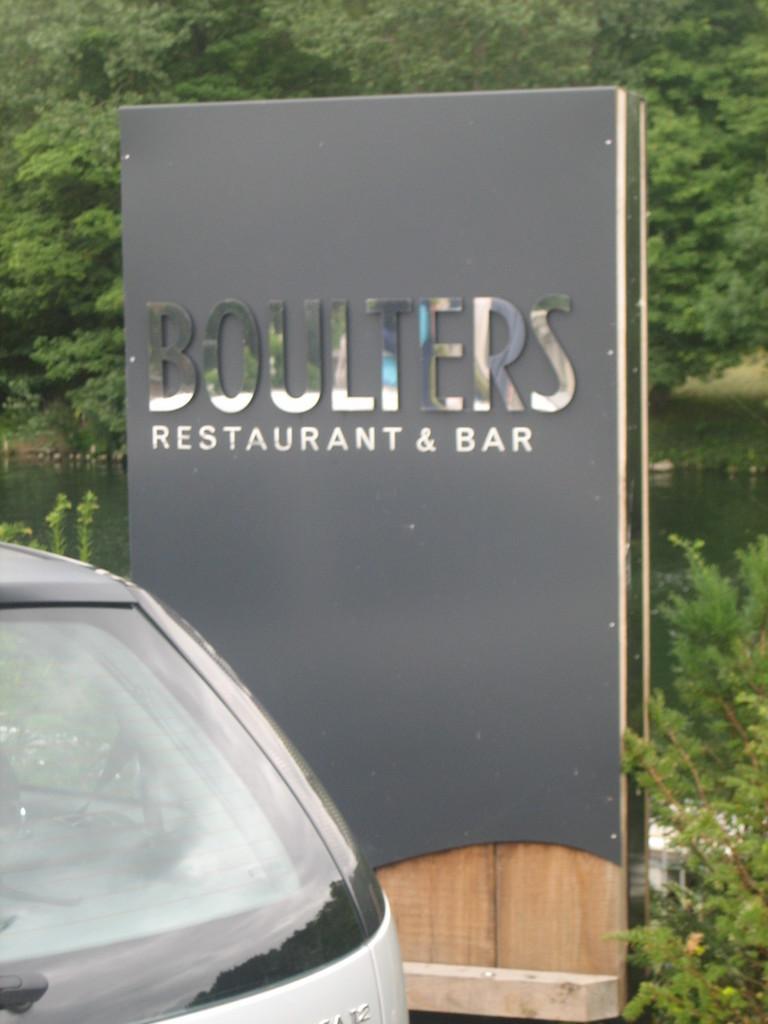In one or two sentences, can you explain what this image depicts? In the foreground of the picture there are plants, board and a car. In the center of the picture there is a water body. In the background there are trees. 